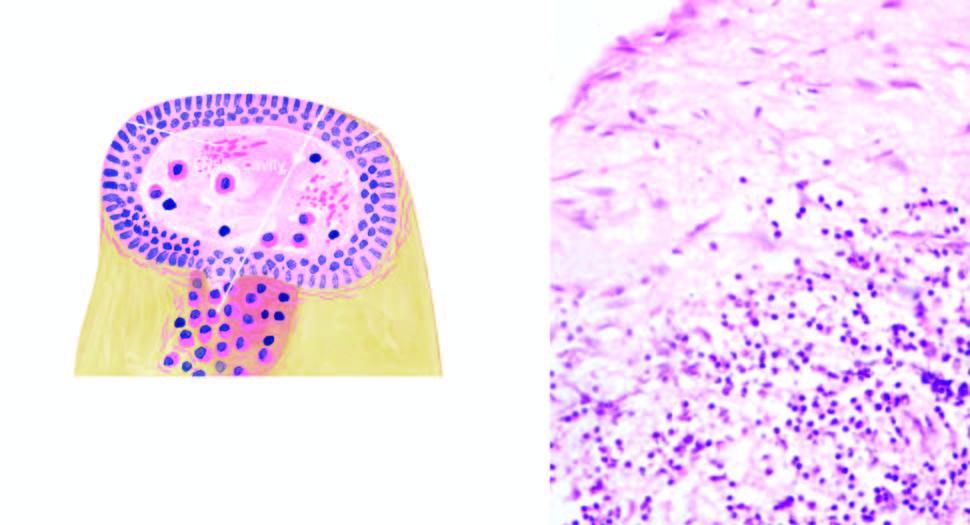what is densely infiltrated by chronic inflammatory cells, chiefly lymphocytes, plasma cells and macrophages?
Answer the question using a single word or phrase. Cyst wall 